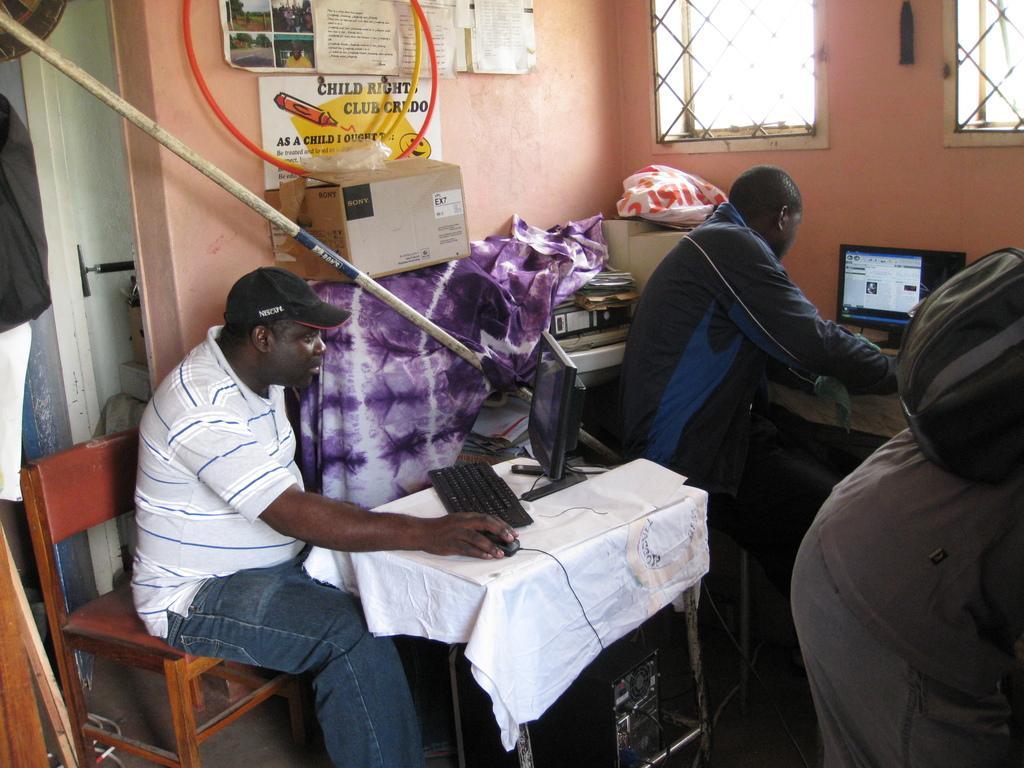Could you give a brief overview of what you see in this image? In this picture we can see two men sitting on chair and operating mouse with their hands and on table we have keyboard, monitor and beside to them we have a pole, box, cloth, files, plastic cover and in the background we can see wall with posters, pipe, window, door. 